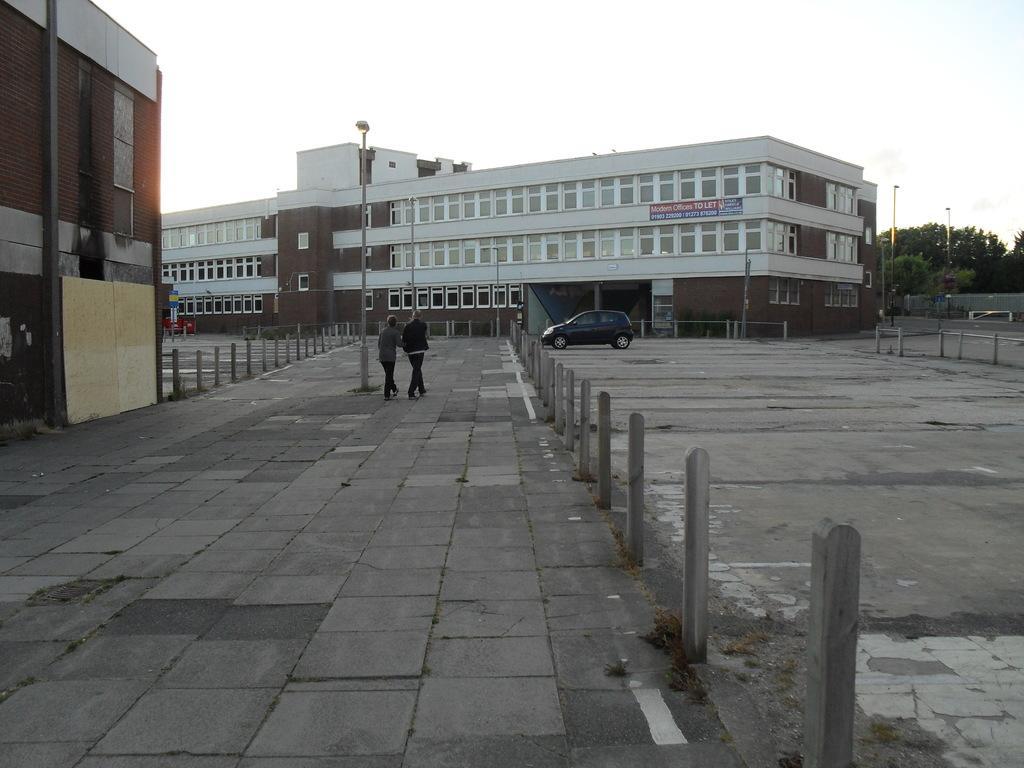Could you give a brief overview of what you see in this image? In this picture I can observe two members walking in this path. On the left side I can observe a pole. There is a car in the middle of the picture. In the background there is a building and sky. 